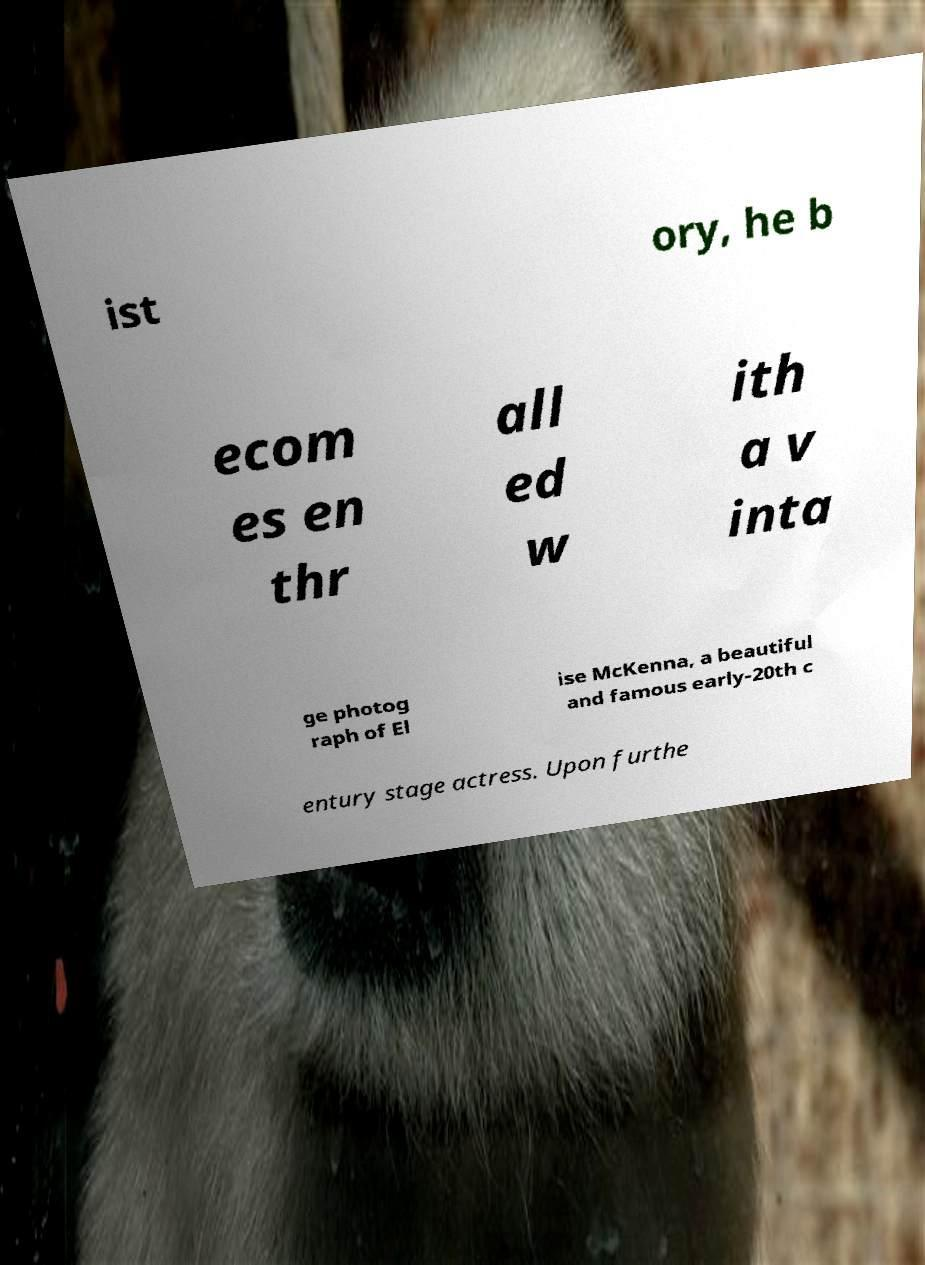What messages or text are displayed in this image? I need them in a readable, typed format. ist ory, he b ecom es en thr all ed w ith a v inta ge photog raph of El ise McKenna, a beautiful and famous early-20th c entury stage actress. Upon furthe 